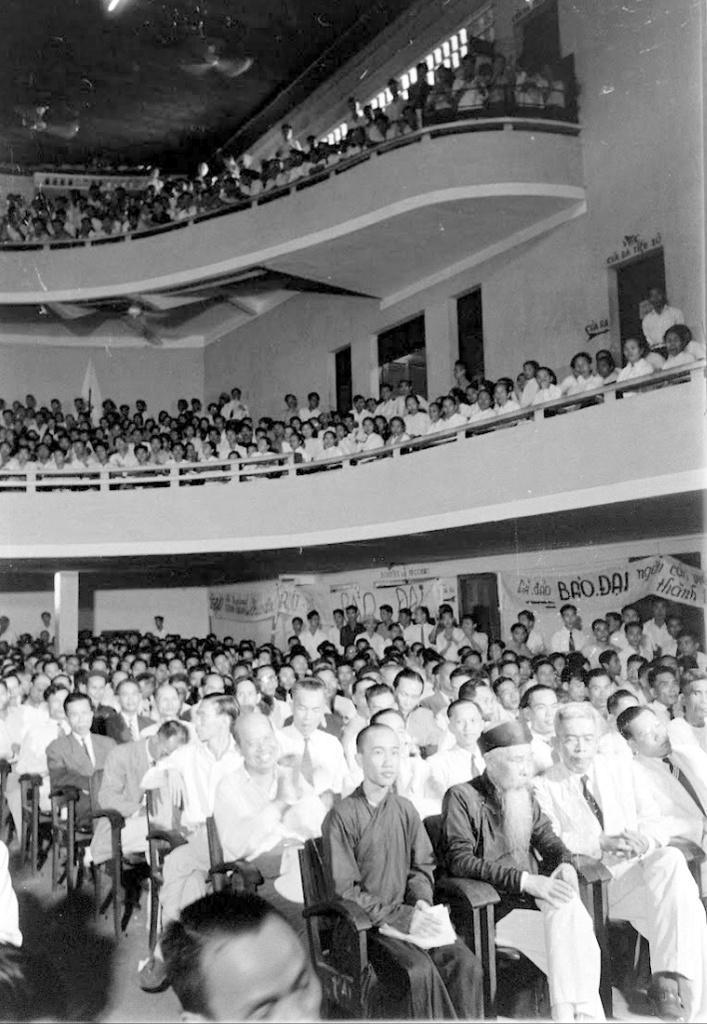In one or two sentences, can you explain what this image depicts? It is a black and white picture. In the center of the image we can see a few people are sitting and a few people are standing. And we can see the front person is holding some object. In the background there is a wall, banners, fences, few people and a few other objects. 